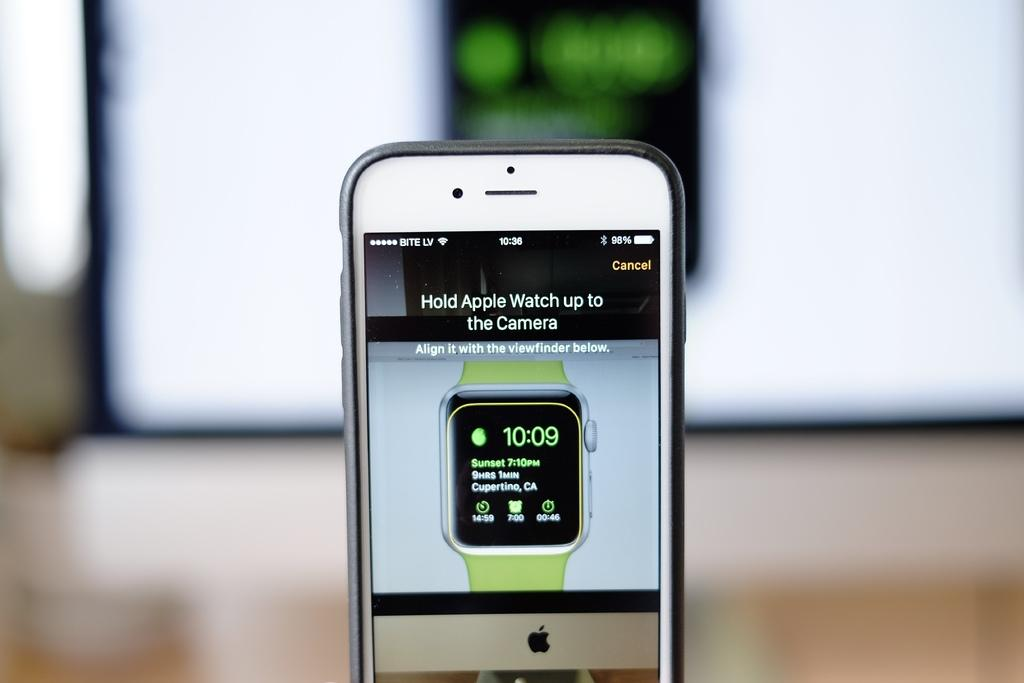<image>
Give a short and clear explanation of the subsequent image. An image if an iPhone showing the words Hold apple watch up to the camera. 